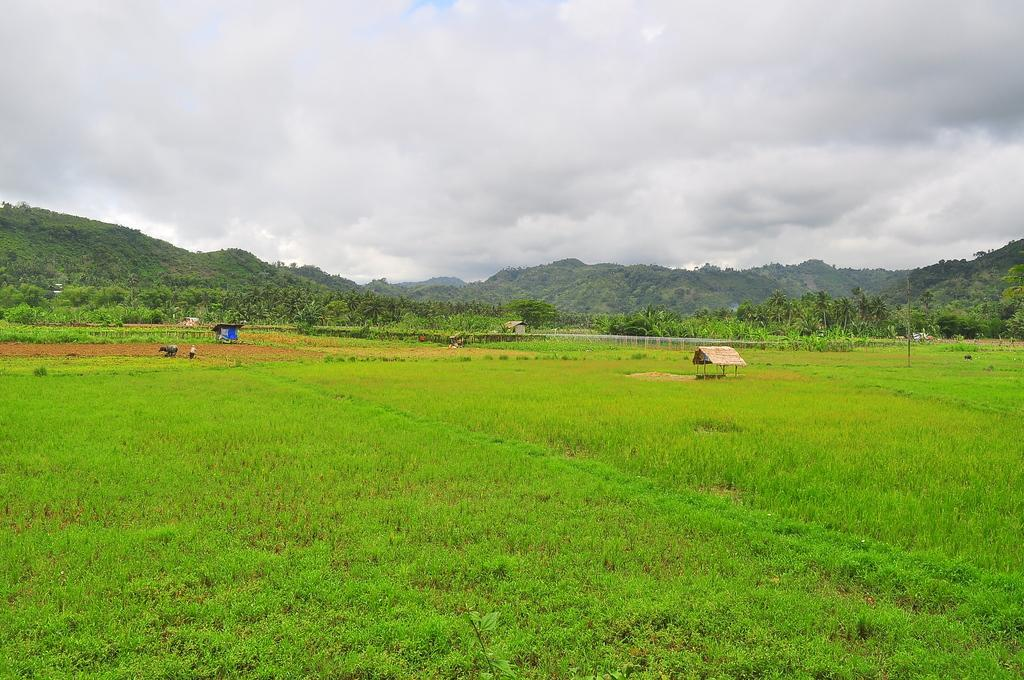What type of vegetation can be seen in the image? There is grass in the image. What can be seen in the background of the image? There are mountains with trees in the background of the image. What type of structure is present in the image? There is a shed in the image. What is visible at the top of the image? The sky is visible at the top of the image. What can be observed in the sky? Clouds are present in the sky. What type of thread is being used to weave the basket in the image? There is no basket present in the image, so it is not possible to determine the type of thread being used. 